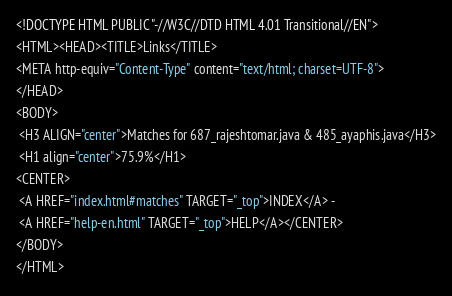<code> <loc_0><loc_0><loc_500><loc_500><_HTML_><!DOCTYPE HTML PUBLIC "-//W3C//DTD HTML 4.01 Transitional//EN">
<HTML><HEAD><TITLE>Links</TITLE>
<META http-equiv="Content-Type" content="text/html; charset=UTF-8">
</HEAD>
<BODY>
 <H3 ALIGN="center">Matches for 687_rajeshtomar.java & 485_ayaphis.java</H3>
 <H1 align="center">75.9%</H1>
<CENTER>
 <A HREF="index.html#matches" TARGET="_top">INDEX</A> - 
 <A HREF="help-en.html" TARGET="_top">HELP</A></CENTER>
</BODY>
</HTML>
</code> 